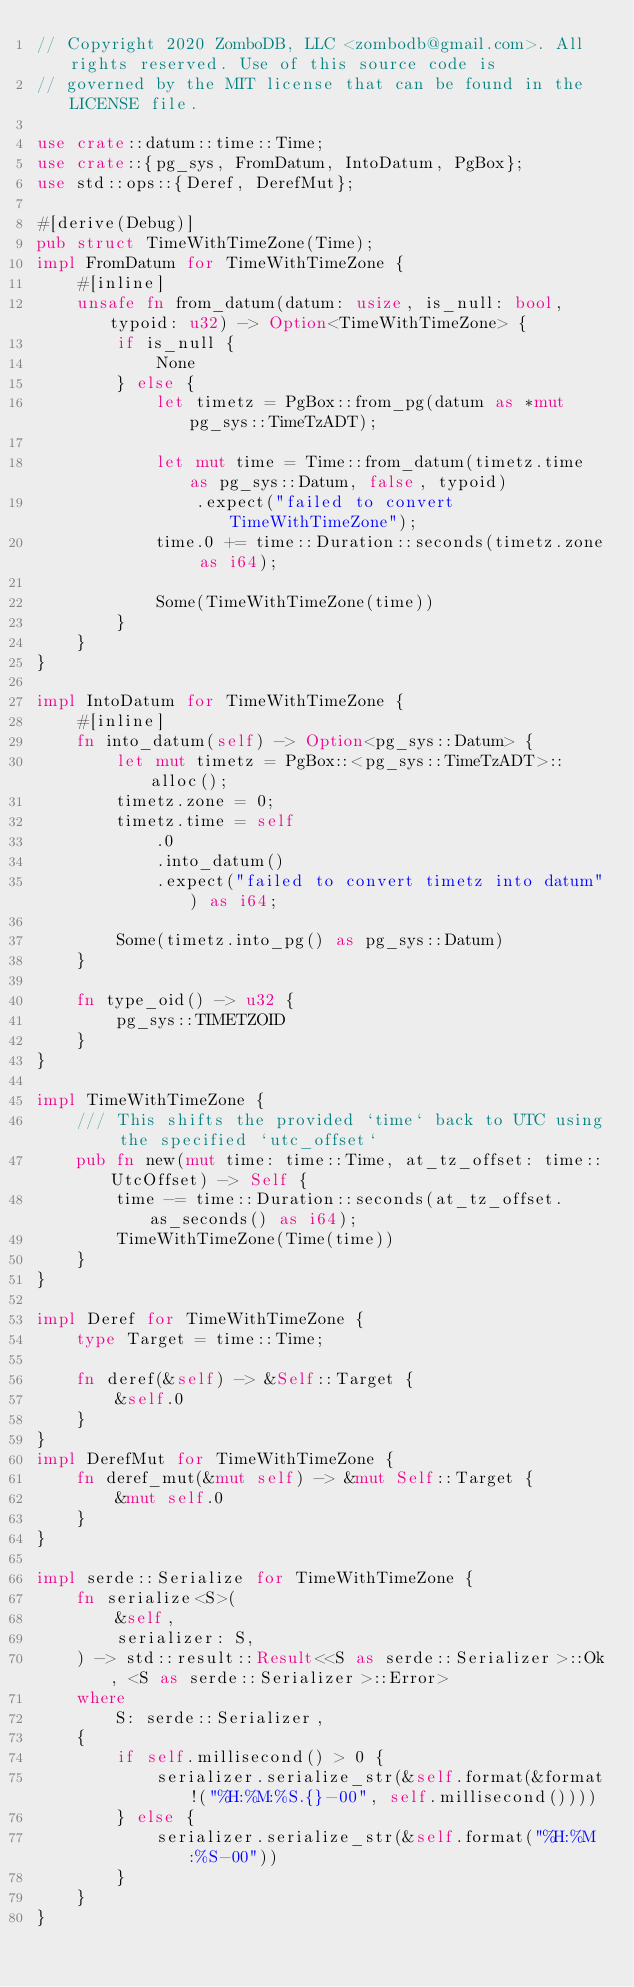<code> <loc_0><loc_0><loc_500><loc_500><_Rust_>// Copyright 2020 ZomboDB, LLC <zombodb@gmail.com>. All rights reserved. Use of this source code is
// governed by the MIT license that can be found in the LICENSE file.

use crate::datum::time::Time;
use crate::{pg_sys, FromDatum, IntoDatum, PgBox};
use std::ops::{Deref, DerefMut};

#[derive(Debug)]
pub struct TimeWithTimeZone(Time);
impl FromDatum for TimeWithTimeZone {
    #[inline]
    unsafe fn from_datum(datum: usize, is_null: bool, typoid: u32) -> Option<TimeWithTimeZone> {
        if is_null {
            None
        } else {
            let timetz = PgBox::from_pg(datum as *mut pg_sys::TimeTzADT);

            let mut time = Time::from_datum(timetz.time as pg_sys::Datum, false, typoid)
                .expect("failed to convert TimeWithTimeZone");
            time.0 += time::Duration::seconds(timetz.zone as i64);

            Some(TimeWithTimeZone(time))
        }
    }
}

impl IntoDatum for TimeWithTimeZone {
    #[inline]
    fn into_datum(self) -> Option<pg_sys::Datum> {
        let mut timetz = PgBox::<pg_sys::TimeTzADT>::alloc();
        timetz.zone = 0;
        timetz.time = self
            .0
            .into_datum()
            .expect("failed to convert timetz into datum") as i64;

        Some(timetz.into_pg() as pg_sys::Datum)
    }

    fn type_oid() -> u32 {
        pg_sys::TIMETZOID
    }
}

impl TimeWithTimeZone {
    /// This shifts the provided `time` back to UTC using the specified `utc_offset`
    pub fn new(mut time: time::Time, at_tz_offset: time::UtcOffset) -> Self {
        time -= time::Duration::seconds(at_tz_offset.as_seconds() as i64);
        TimeWithTimeZone(Time(time))
    }
}

impl Deref for TimeWithTimeZone {
    type Target = time::Time;

    fn deref(&self) -> &Self::Target {
        &self.0
    }
}
impl DerefMut for TimeWithTimeZone {
    fn deref_mut(&mut self) -> &mut Self::Target {
        &mut self.0
    }
}

impl serde::Serialize for TimeWithTimeZone {
    fn serialize<S>(
        &self,
        serializer: S,
    ) -> std::result::Result<<S as serde::Serializer>::Ok, <S as serde::Serializer>::Error>
    where
        S: serde::Serializer,
    {
        if self.millisecond() > 0 {
            serializer.serialize_str(&self.format(&format!("%H:%M:%S.{}-00", self.millisecond())))
        } else {
            serializer.serialize_str(&self.format("%H:%M:%S-00"))
        }
    }
}
</code> 